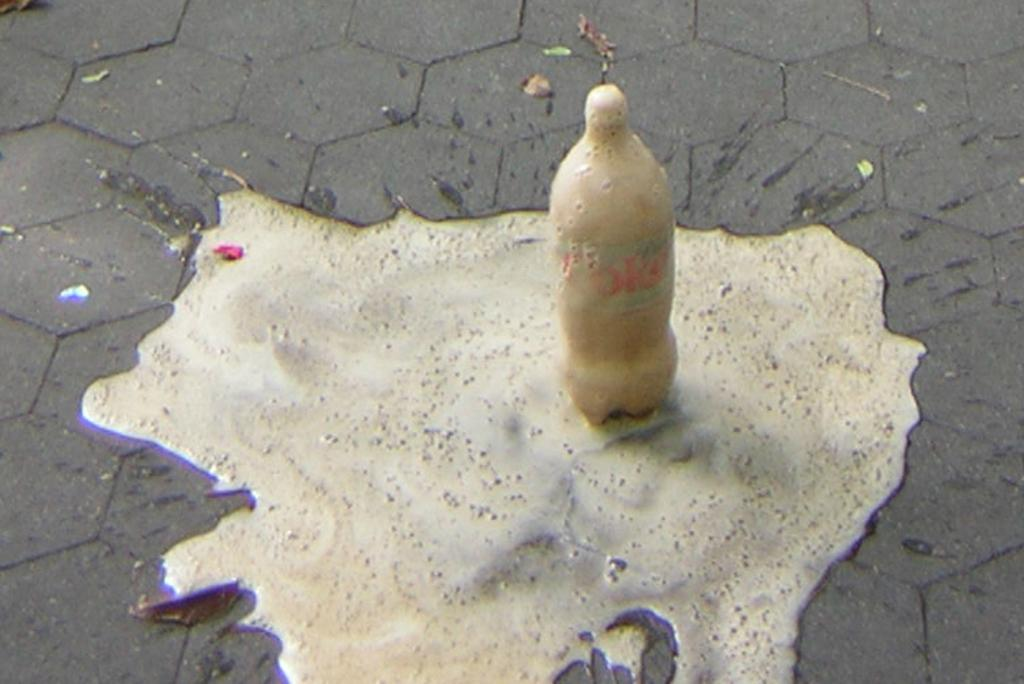What is on the floor in the image? There is a coke bottle on the floor in the image. How many frogs are sitting on the coke bottle in the image? There are no frogs present in the image, and therefore no frogs are sitting on the coke bottle. Is there a swing visible in the image? There is no swing present in the image. 